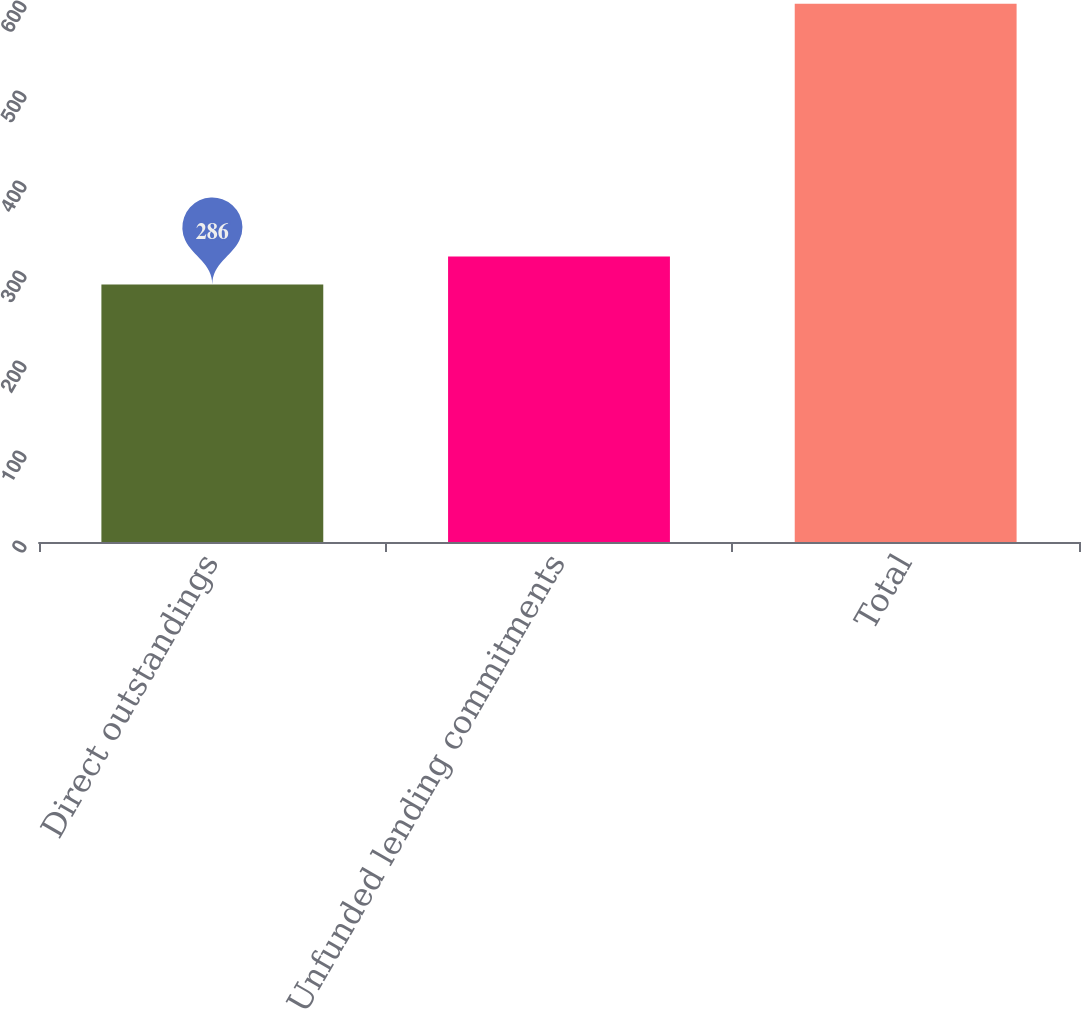Convert chart to OTSL. <chart><loc_0><loc_0><loc_500><loc_500><bar_chart><fcel>Direct outstandings<fcel>Unfunded lending commitments<fcel>Total<nl><fcel>286<fcel>317.2<fcel>598<nl></chart> 